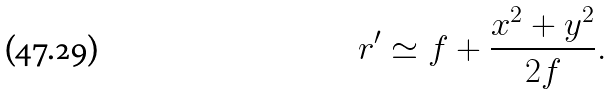<formula> <loc_0><loc_0><loc_500><loc_500>r ^ { \prime } \simeq f + \frac { x ^ { 2 } + y ^ { 2 } } { 2 f } .</formula> 